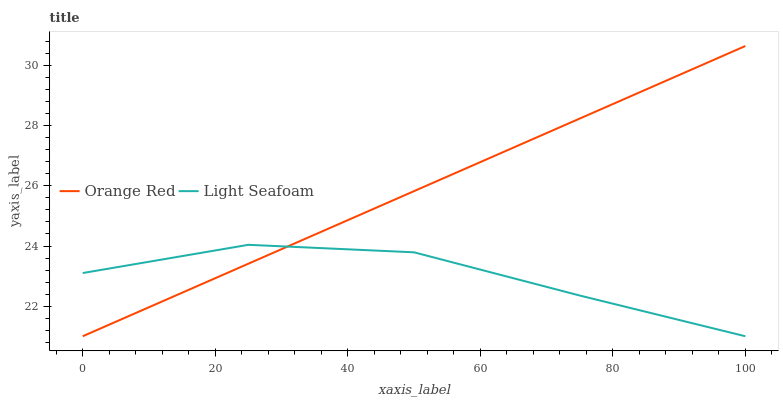Does Light Seafoam have the minimum area under the curve?
Answer yes or no. Yes. Does Orange Red have the maximum area under the curve?
Answer yes or no. Yes. Does Orange Red have the minimum area under the curve?
Answer yes or no. No. Is Orange Red the smoothest?
Answer yes or no. Yes. Is Light Seafoam the roughest?
Answer yes or no. Yes. Is Orange Red the roughest?
Answer yes or no. No. Does Light Seafoam have the lowest value?
Answer yes or no. Yes. Does Orange Red have the highest value?
Answer yes or no. Yes. Does Light Seafoam intersect Orange Red?
Answer yes or no. Yes. Is Light Seafoam less than Orange Red?
Answer yes or no. No. Is Light Seafoam greater than Orange Red?
Answer yes or no. No. 